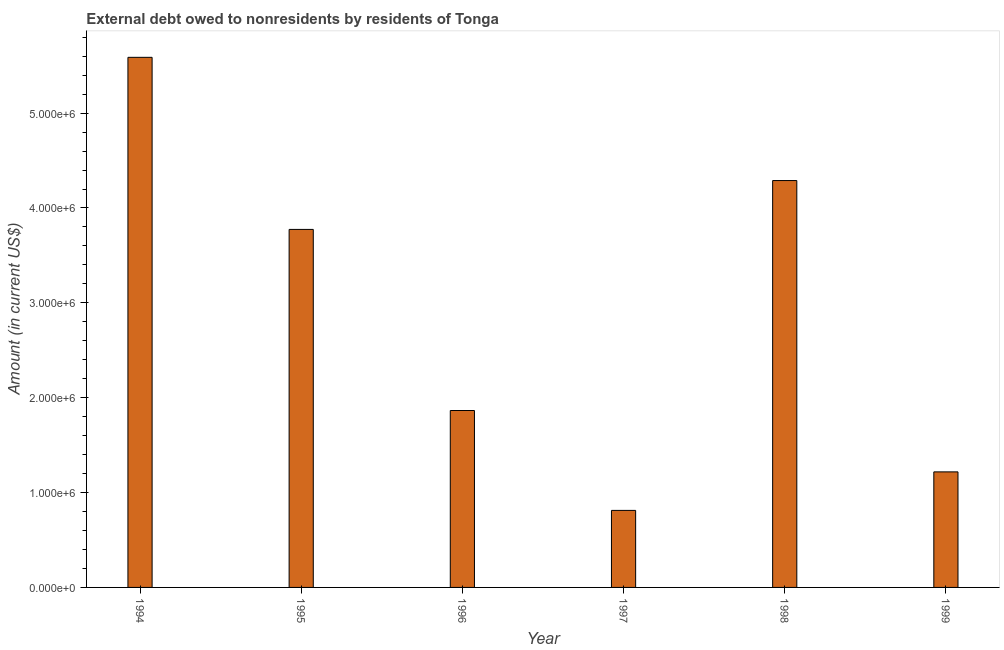Does the graph contain grids?
Your answer should be compact. No. What is the title of the graph?
Provide a succinct answer. External debt owed to nonresidents by residents of Tonga. What is the debt in 1998?
Give a very brief answer. 4.29e+06. Across all years, what is the maximum debt?
Provide a succinct answer. 5.59e+06. Across all years, what is the minimum debt?
Make the answer very short. 8.12e+05. What is the sum of the debt?
Offer a terse response. 1.75e+07. What is the difference between the debt in 1997 and 1998?
Offer a very short reply. -3.48e+06. What is the average debt per year?
Your answer should be very brief. 2.92e+06. What is the median debt?
Provide a short and direct response. 2.82e+06. In how many years, is the debt greater than 600000 US$?
Your answer should be compact. 6. What is the ratio of the debt in 1995 to that in 1996?
Your response must be concise. 2.02. What is the difference between the highest and the second highest debt?
Your answer should be compact. 1.30e+06. What is the difference between the highest and the lowest debt?
Give a very brief answer. 4.78e+06. Are all the bars in the graph horizontal?
Your answer should be compact. No. How many years are there in the graph?
Your answer should be compact. 6. What is the difference between two consecutive major ticks on the Y-axis?
Provide a succinct answer. 1.00e+06. Are the values on the major ticks of Y-axis written in scientific E-notation?
Offer a very short reply. Yes. What is the Amount (in current US$) of 1994?
Offer a very short reply. 5.59e+06. What is the Amount (in current US$) of 1995?
Provide a short and direct response. 3.77e+06. What is the Amount (in current US$) in 1996?
Provide a succinct answer. 1.86e+06. What is the Amount (in current US$) in 1997?
Your answer should be compact. 8.12e+05. What is the Amount (in current US$) of 1998?
Your answer should be compact. 4.29e+06. What is the Amount (in current US$) in 1999?
Offer a very short reply. 1.22e+06. What is the difference between the Amount (in current US$) in 1994 and 1995?
Make the answer very short. 1.81e+06. What is the difference between the Amount (in current US$) in 1994 and 1996?
Offer a very short reply. 3.72e+06. What is the difference between the Amount (in current US$) in 1994 and 1997?
Keep it short and to the point. 4.78e+06. What is the difference between the Amount (in current US$) in 1994 and 1998?
Ensure brevity in your answer.  1.30e+06. What is the difference between the Amount (in current US$) in 1994 and 1999?
Make the answer very short. 4.37e+06. What is the difference between the Amount (in current US$) in 1995 and 1996?
Make the answer very short. 1.91e+06. What is the difference between the Amount (in current US$) in 1995 and 1997?
Provide a short and direct response. 2.96e+06. What is the difference between the Amount (in current US$) in 1995 and 1998?
Your answer should be very brief. -5.15e+05. What is the difference between the Amount (in current US$) in 1995 and 1999?
Your answer should be very brief. 2.56e+06. What is the difference between the Amount (in current US$) in 1996 and 1997?
Provide a short and direct response. 1.05e+06. What is the difference between the Amount (in current US$) in 1996 and 1998?
Provide a succinct answer. -2.42e+06. What is the difference between the Amount (in current US$) in 1996 and 1999?
Your answer should be compact. 6.47e+05. What is the difference between the Amount (in current US$) in 1997 and 1998?
Your response must be concise. -3.48e+06. What is the difference between the Amount (in current US$) in 1997 and 1999?
Keep it short and to the point. -4.06e+05. What is the difference between the Amount (in current US$) in 1998 and 1999?
Your answer should be very brief. 3.07e+06. What is the ratio of the Amount (in current US$) in 1994 to that in 1995?
Ensure brevity in your answer.  1.48. What is the ratio of the Amount (in current US$) in 1994 to that in 1996?
Offer a very short reply. 3. What is the ratio of the Amount (in current US$) in 1994 to that in 1997?
Offer a very short reply. 6.88. What is the ratio of the Amount (in current US$) in 1994 to that in 1998?
Offer a terse response. 1.3. What is the ratio of the Amount (in current US$) in 1994 to that in 1999?
Your answer should be very brief. 4.59. What is the ratio of the Amount (in current US$) in 1995 to that in 1996?
Provide a succinct answer. 2.02. What is the ratio of the Amount (in current US$) in 1995 to that in 1997?
Your answer should be compact. 4.65. What is the ratio of the Amount (in current US$) in 1995 to that in 1999?
Provide a short and direct response. 3.1. What is the ratio of the Amount (in current US$) in 1996 to that in 1997?
Your answer should be very brief. 2.3. What is the ratio of the Amount (in current US$) in 1996 to that in 1998?
Offer a very short reply. 0.43. What is the ratio of the Amount (in current US$) in 1996 to that in 1999?
Provide a short and direct response. 1.53. What is the ratio of the Amount (in current US$) in 1997 to that in 1998?
Give a very brief answer. 0.19. What is the ratio of the Amount (in current US$) in 1997 to that in 1999?
Offer a very short reply. 0.67. What is the ratio of the Amount (in current US$) in 1998 to that in 1999?
Provide a succinct answer. 3.52. 